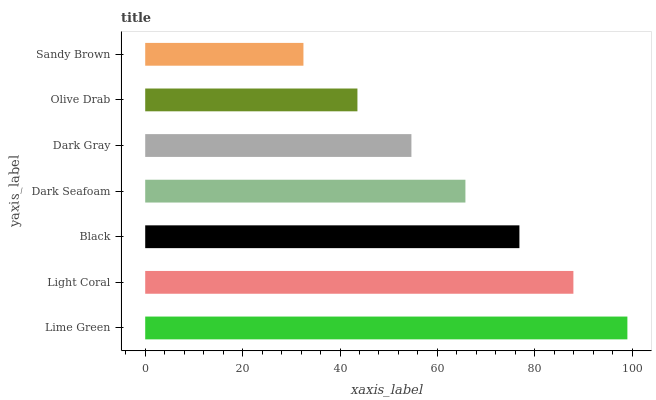Is Sandy Brown the minimum?
Answer yes or no. Yes. Is Lime Green the maximum?
Answer yes or no. Yes. Is Light Coral the minimum?
Answer yes or no. No. Is Light Coral the maximum?
Answer yes or no. No. Is Lime Green greater than Light Coral?
Answer yes or no. Yes. Is Light Coral less than Lime Green?
Answer yes or no. Yes. Is Light Coral greater than Lime Green?
Answer yes or no. No. Is Lime Green less than Light Coral?
Answer yes or no. No. Is Dark Seafoam the high median?
Answer yes or no. Yes. Is Dark Seafoam the low median?
Answer yes or no. Yes. Is Light Coral the high median?
Answer yes or no. No. Is Lime Green the low median?
Answer yes or no. No. 